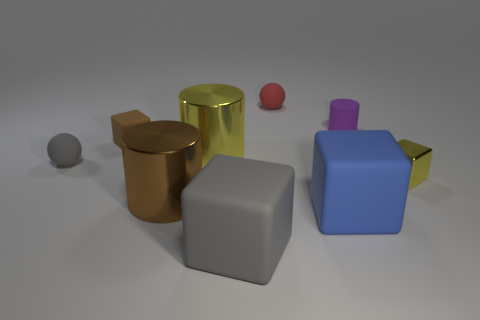Subtract all yellow metal cubes. How many cubes are left? 3 Add 1 large blue metallic balls. How many objects exist? 10 Subtract all yellow cubes. How many cubes are left? 3 Subtract all cylinders. How many objects are left? 6 Subtract 2 cylinders. How many cylinders are left? 1 Subtract all yellow spheres. Subtract all yellow cylinders. How many spheres are left? 2 Subtract all blue cylinders. How many green spheres are left? 0 Subtract all small red balls. Subtract all big yellow things. How many objects are left? 7 Add 5 purple rubber cylinders. How many purple rubber cylinders are left? 6 Add 8 big yellow shiny objects. How many big yellow shiny objects exist? 9 